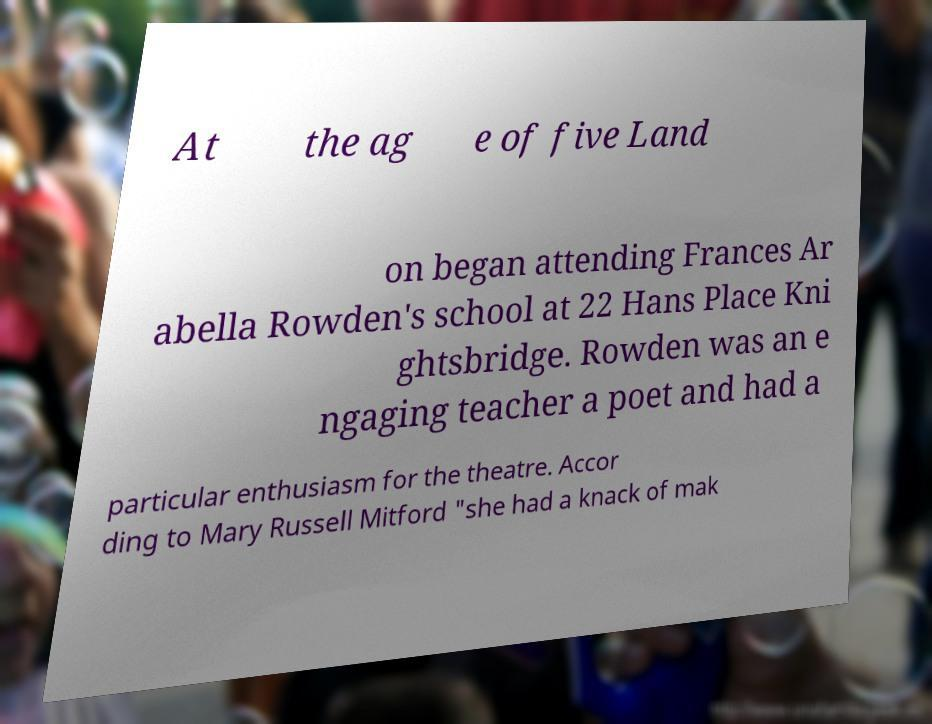Please identify and transcribe the text found in this image. At the ag e of five Land on began attending Frances Ar abella Rowden's school at 22 Hans Place Kni ghtsbridge. Rowden was an e ngaging teacher a poet and had a particular enthusiasm for the theatre. Accor ding to Mary Russell Mitford "she had a knack of mak 